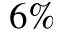<formula> <loc_0><loc_0><loc_500><loc_500>6 \%</formula> 